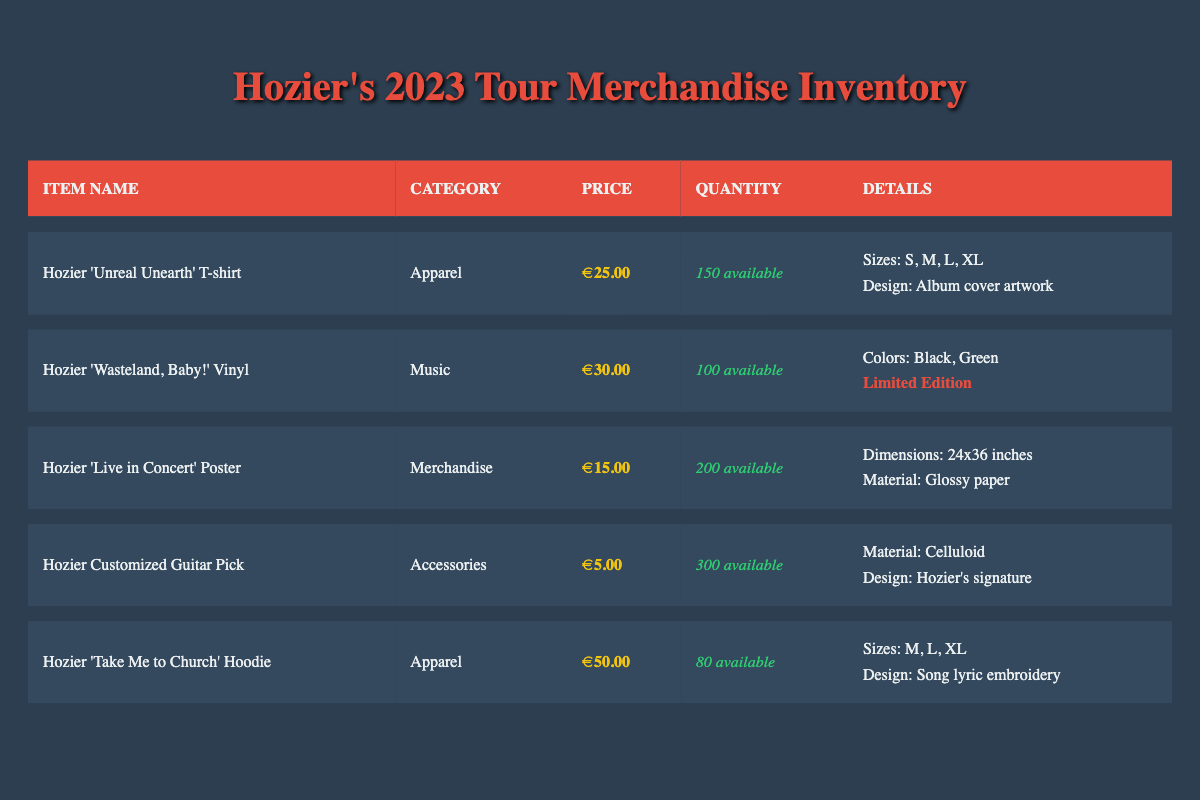What is the price of the Hozier 'Unreal Unearth' T-shirt? The price of the Hozier 'Unreal Unearth' T-shirt is listed directly under the price column for that item, which shows €25.00.
Answer: €25.00 How many Hozier 'Take Me to Church' Hoodies are available? The quantity available for the Hozier 'Take Me to Church' Hoodie can be found in the quantity column for that specific item, which states that there are 80 available.
Answer: 80 Is the 'Wasteland, Baby!' Vinyl a limited edition? The information about whether the 'Wasteland, Baby!' Vinyl is a limited edition is indicated by the special note in the details column for that item, which clearly marks it as "Limited Edition."
Answer: Yes What is the total quantity available of all items in the Apparel category? To find the total quantity of all items in the Apparel category, I will sum the quantities available for each applicable item: 150 (Unreal Unearth T-shirt) + 80 (Take Me to Church Hoodie) = 230. Thus, the total quantity available in the Apparel category is 230.
Answer: 230 Which item has the highest price, and what is that price? I will compare the prices of all items in the table: €25.00 (T-shirt), €30.00 (Vinyl), €15.00 (Poster), €5.00 (Guitar Pick), €50.00 (Hoodie). The highest price is €50.00 for the Hozier 'Take Me to Church' Hoodie.
Answer: Hozier 'Take Me to Church' Hoodie, €50.00 How many color options are available for the 'Wasteland, Baby!' Vinyl? The color options for the 'Wasteland, Baby!' Vinyl are listed in the details for that item, showing there are two available colors: Black and Green. Therefore, there are 2 color options.
Answer: 2 What material is used for the Customized Guitar Pick? The material for the Customized Guitar Pick is specified in the details column for that item, which indicates it is made of Celluloid.
Answer: Celluloid Which item in the inventory has the largest quantity available? I will compare the quantity available for each item: 150 (T-shirt), 100 (Vinyl), 200 (Poster), 300 (Guitar Pick), and 80 (Hoodie). The item with the largest quantity is the Hozier Customized Guitar Pick with 300 available.
Answer: Hozier Customized Guitar Pick What is the average price of all items in the inventory? To calculate the average price, I add the prices of all items: €25.00 (T-shirt) + €30.00 (Vinyl) + €15.00 (Poster) + €5.00 (Guitar Pick) + €50.00 (Hoodie) = €125.00. There are 5 items, so the average price is €125.00 divided by 5, which equals €25.00.
Answer: €25.00 